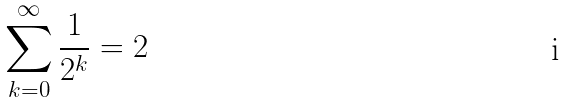<formula> <loc_0><loc_0><loc_500><loc_500>\sum _ { k = 0 } ^ { \infty } \frac { 1 } { 2 ^ { k } } = 2</formula> 